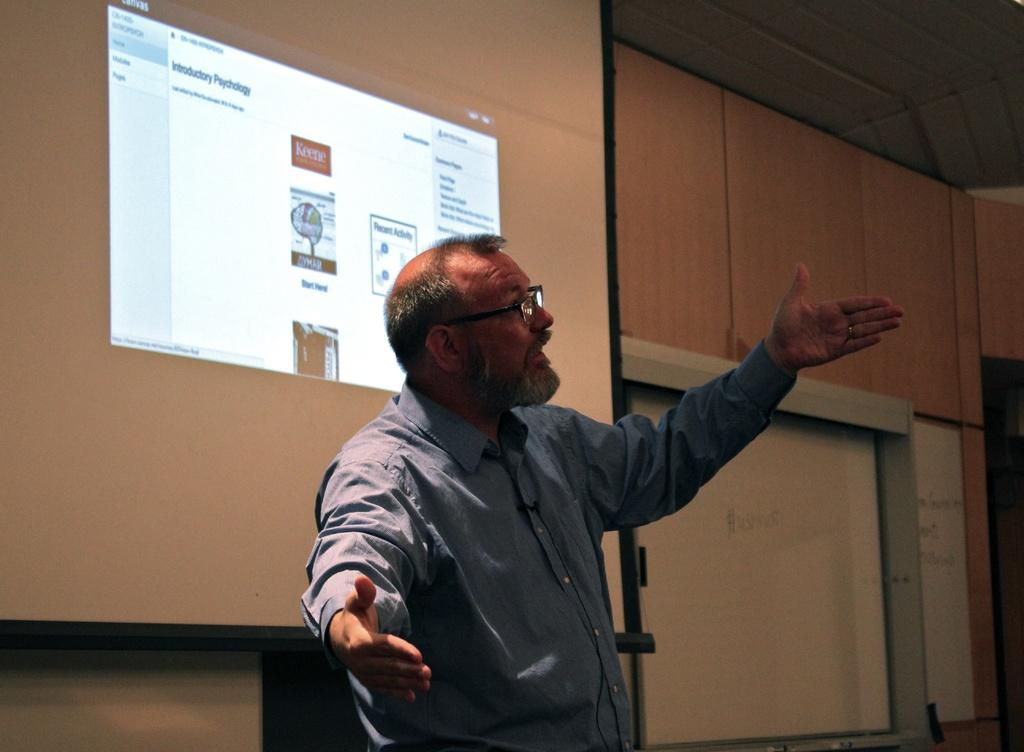What is the man in the image wearing? The man is wearing a blue shirt and spectacles. What can be seen on the wall in the image? There are wooden boards attached to the wall. What is the purpose of the screen with a display in the image? The purpose of the screen with a display is not specified, but it could be for presenting information or displaying images. What is the color of the whiteboard in the image? The whiteboard in the image is white. What type of sand can be seen on the floor in the image? There is no sand present on the floor in the image. Can you describe the cloud formation visible through the window in the image? There is no window or cloud formation visible in the image. 